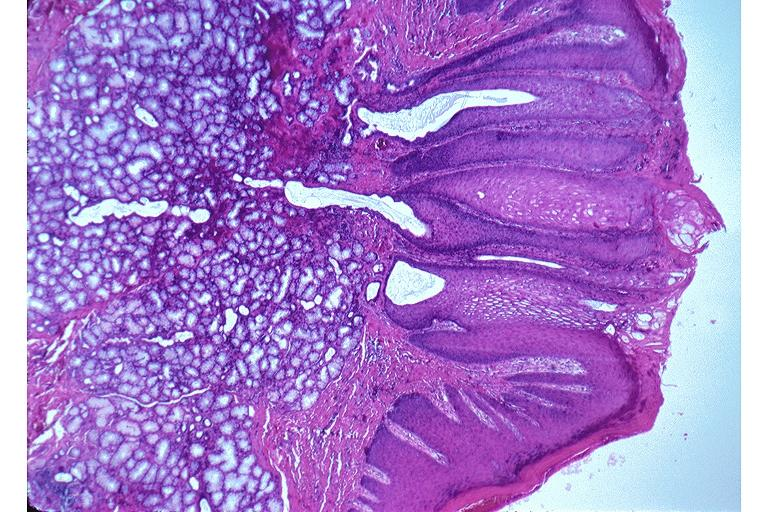does this image show nicotine stomatitis?
Answer the question using a single word or phrase. Yes 